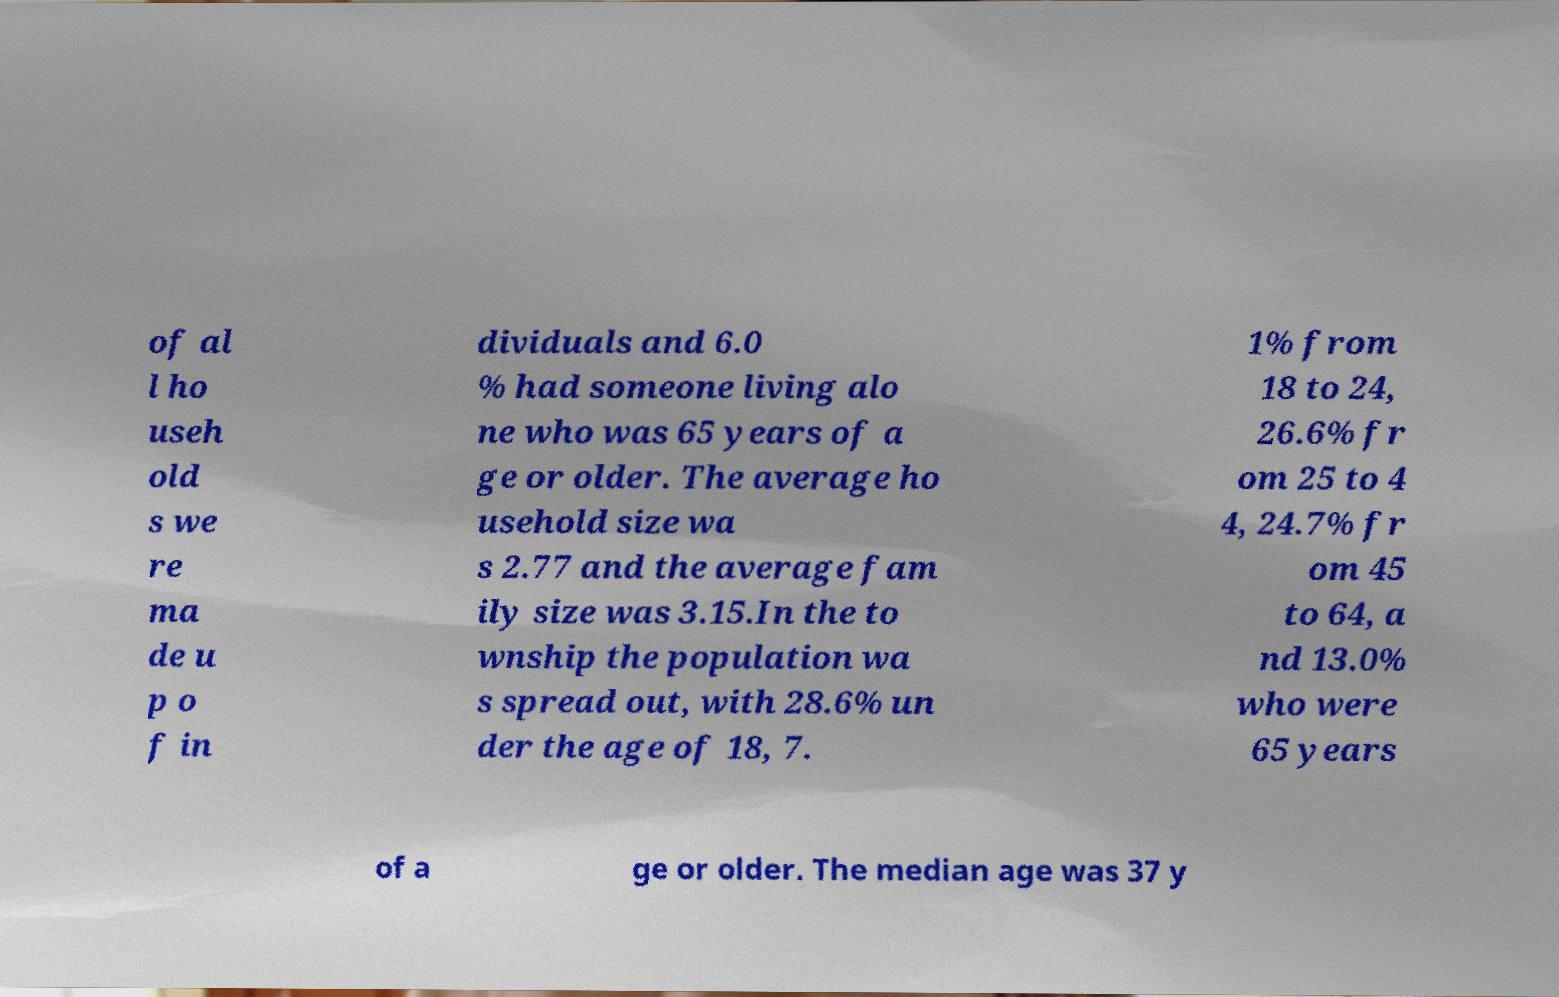Please identify and transcribe the text found in this image. of al l ho useh old s we re ma de u p o f in dividuals and 6.0 % had someone living alo ne who was 65 years of a ge or older. The average ho usehold size wa s 2.77 and the average fam ily size was 3.15.In the to wnship the population wa s spread out, with 28.6% un der the age of 18, 7. 1% from 18 to 24, 26.6% fr om 25 to 4 4, 24.7% fr om 45 to 64, a nd 13.0% who were 65 years of a ge or older. The median age was 37 y 